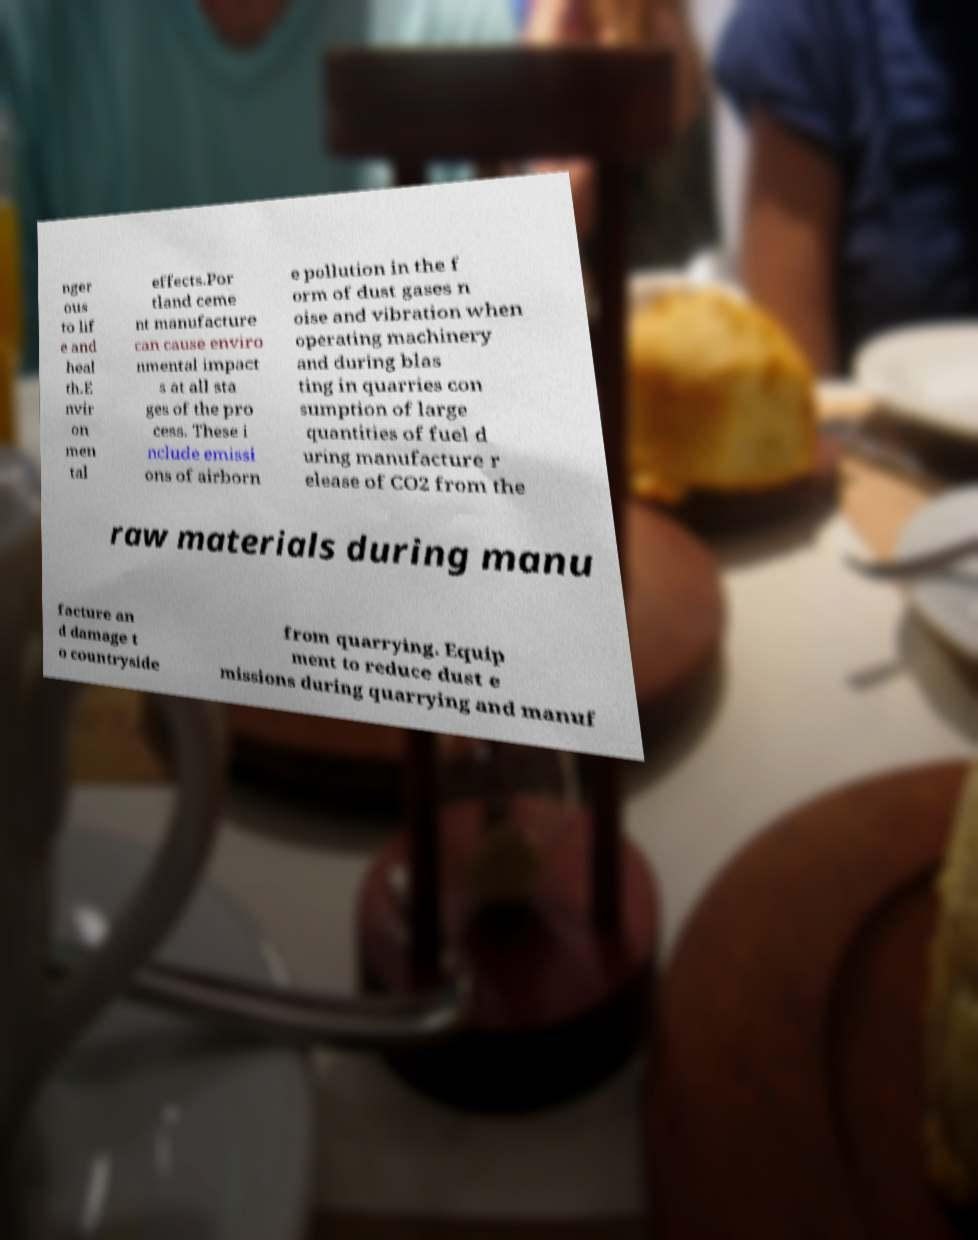What messages or text are displayed in this image? I need them in a readable, typed format. nger ous to lif e and heal th.E nvir on men tal effects.Por tland ceme nt manufacture can cause enviro nmental impact s at all sta ges of the pro cess. These i nclude emissi ons of airborn e pollution in the f orm of dust gases n oise and vibration when operating machinery and during blas ting in quarries con sumption of large quantities of fuel d uring manufacture r elease of CO2 from the raw materials during manu facture an d damage t o countryside from quarrying. Equip ment to reduce dust e missions during quarrying and manuf 